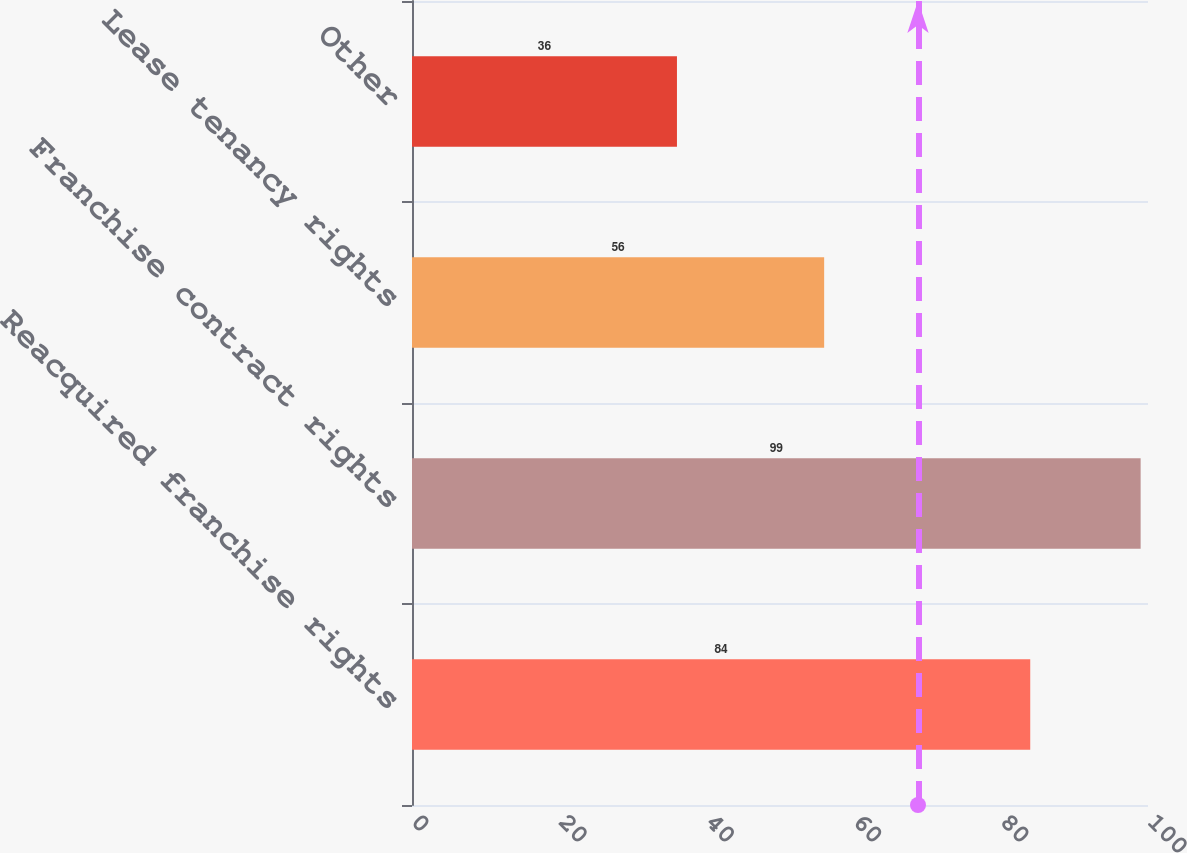Convert chart. <chart><loc_0><loc_0><loc_500><loc_500><bar_chart><fcel>Reacquired franchise rights<fcel>Franchise contract rights<fcel>Lease tenancy rights<fcel>Other<nl><fcel>84<fcel>99<fcel>56<fcel>36<nl></chart> 